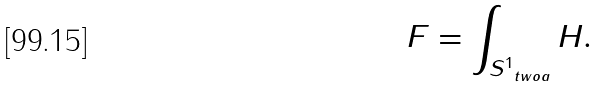Convert formula to latex. <formula><loc_0><loc_0><loc_500><loc_500>F = \int _ { S ^ { 1 } _ { \ t w o a } } H .</formula> 